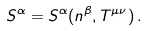Convert formula to latex. <formula><loc_0><loc_0><loc_500><loc_500>S ^ { \alpha } = S ^ { \alpha } ( n ^ { \beta } , T ^ { \mu \nu } ) \, .</formula> 